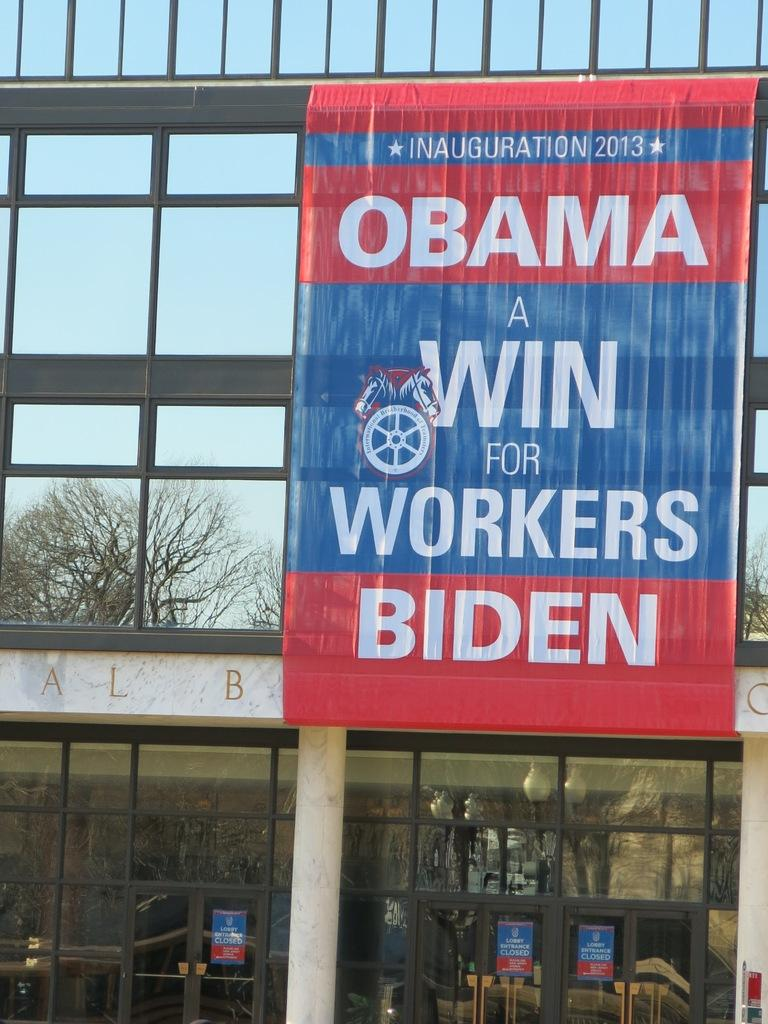What is hanging on the wall of the building in the image? There is a banner in the image. What can be seen on the banner? The banner has text on it. What type of string is used to hang the banner in the image? There is no mention of a string being used to hang the banner in the image. 